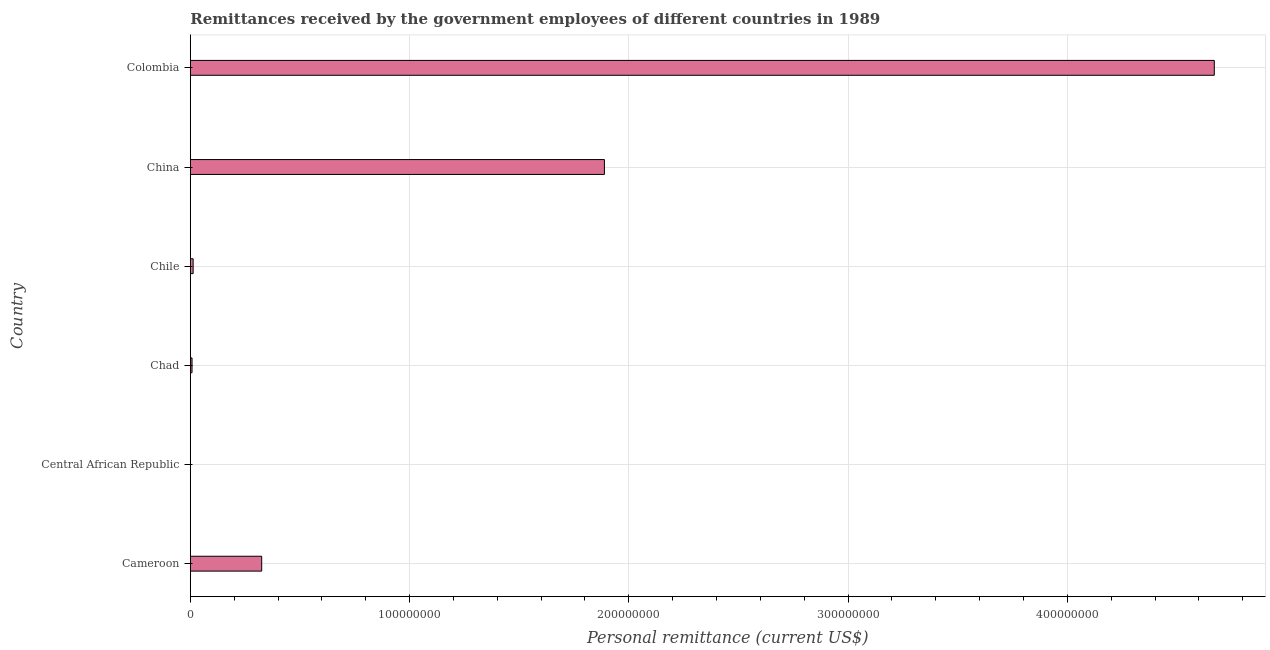Does the graph contain any zero values?
Give a very brief answer. No. Does the graph contain grids?
Offer a very short reply. Yes. What is the title of the graph?
Make the answer very short. Remittances received by the government employees of different countries in 1989. What is the label or title of the X-axis?
Your answer should be very brief. Personal remittance (current US$). What is the label or title of the Y-axis?
Give a very brief answer. Country. What is the personal remittances in Central African Republic?
Your answer should be compact. 2.19e+04. Across all countries, what is the maximum personal remittances?
Make the answer very short. 4.67e+08. Across all countries, what is the minimum personal remittances?
Offer a terse response. 2.19e+04. In which country was the personal remittances minimum?
Your answer should be compact. Central African Republic. What is the sum of the personal remittances?
Make the answer very short. 6.91e+08. What is the difference between the personal remittances in Central African Republic and Chad?
Offer a very short reply. -7.71e+05. What is the average personal remittances per country?
Your response must be concise. 1.15e+08. What is the median personal remittances?
Provide a succinct answer. 1.69e+07. What is the ratio of the personal remittances in Cameroon to that in Colombia?
Provide a short and direct response. 0.07. Is the personal remittances in Central African Republic less than that in Colombia?
Make the answer very short. Yes. Is the difference between the personal remittances in China and Colombia greater than the difference between any two countries?
Make the answer very short. No. What is the difference between the highest and the second highest personal remittances?
Offer a very short reply. 2.78e+08. What is the difference between the highest and the lowest personal remittances?
Your answer should be very brief. 4.67e+08. In how many countries, is the personal remittances greater than the average personal remittances taken over all countries?
Your answer should be compact. 2. How many bars are there?
Keep it short and to the point. 6. Are all the bars in the graph horizontal?
Ensure brevity in your answer.  Yes. How many countries are there in the graph?
Provide a succinct answer. 6. What is the difference between two consecutive major ticks on the X-axis?
Ensure brevity in your answer.  1.00e+08. What is the Personal remittance (current US$) in Cameroon?
Your response must be concise. 3.26e+07. What is the Personal remittance (current US$) of Central African Republic?
Provide a short and direct response. 2.19e+04. What is the Personal remittance (current US$) in Chad?
Your answer should be very brief. 7.93e+05. What is the Personal remittance (current US$) in Chile?
Provide a short and direct response. 1.30e+06. What is the Personal remittance (current US$) in China?
Your answer should be very brief. 1.89e+08. What is the Personal remittance (current US$) of Colombia?
Make the answer very short. 4.67e+08. What is the difference between the Personal remittance (current US$) in Cameroon and Central African Republic?
Give a very brief answer. 3.25e+07. What is the difference between the Personal remittance (current US$) in Cameroon and Chad?
Your response must be concise. 3.18e+07. What is the difference between the Personal remittance (current US$) in Cameroon and Chile?
Ensure brevity in your answer.  3.13e+07. What is the difference between the Personal remittance (current US$) in Cameroon and China?
Your response must be concise. -1.56e+08. What is the difference between the Personal remittance (current US$) in Cameroon and Colombia?
Offer a terse response. -4.34e+08. What is the difference between the Personal remittance (current US$) in Central African Republic and Chad?
Ensure brevity in your answer.  -7.71e+05. What is the difference between the Personal remittance (current US$) in Central African Republic and Chile?
Offer a terse response. -1.28e+06. What is the difference between the Personal remittance (current US$) in Central African Republic and China?
Ensure brevity in your answer.  -1.89e+08. What is the difference between the Personal remittance (current US$) in Central African Republic and Colombia?
Give a very brief answer. -4.67e+08. What is the difference between the Personal remittance (current US$) in Chad and Chile?
Provide a succinct answer. -5.07e+05. What is the difference between the Personal remittance (current US$) in Chad and China?
Your response must be concise. -1.88e+08. What is the difference between the Personal remittance (current US$) in Chad and Colombia?
Your answer should be compact. -4.66e+08. What is the difference between the Personal remittance (current US$) in Chile and China?
Offer a terse response. -1.88e+08. What is the difference between the Personal remittance (current US$) in Chile and Colombia?
Your answer should be compact. -4.66e+08. What is the difference between the Personal remittance (current US$) in China and Colombia?
Give a very brief answer. -2.78e+08. What is the ratio of the Personal remittance (current US$) in Cameroon to that in Central African Republic?
Give a very brief answer. 1484.29. What is the ratio of the Personal remittance (current US$) in Cameroon to that in Chad?
Keep it short and to the point. 41.07. What is the ratio of the Personal remittance (current US$) in Cameroon to that in Chile?
Your response must be concise. 25.05. What is the ratio of the Personal remittance (current US$) in Cameroon to that in China?
Your answer should be compact. 0.17. What is the ratio of the Personal remittance (current US$) in Cameroon to that in Colombia?
Keep it short and to the point. 0.07. What is the ratio of the Personal remittance (current US$) in Central African Republic to that in Chad?
Your response must be concise. 0.03. What is the ratio of the Personal remittance (current US$) in Central African Republic to that in Chile?
Your answer should be compact. 0.02. What is the ratio of the Personal remittance (current US$) in Central African Republic to that in China?
Provide a short and direct response. 0. What is the ratio of the Personal remittance (current US$) in Central African Republic to that in Colombia?
Provide a succinct answer. 0. What is the ratio of the Personal remittance (current US$) in Chad to that in Chile?
Ensure brevity in your answer.  0.61. What is the ratio of the Personal remittance (current US$) in Chad to that in China?
Your response must be concise. 0. What is the ratio of the Personal remittance (current US$) in Chad to that in Colombia?
Offer a very short reply. 0. What is the ratio of the Personal remittance (current US$) in Chile to that in China?
Ensure brevity in your answer.  0.01. What is the ratio of the Personal remittance (current US$) in Chile to that in Colombia?
Make the answer very short. 0. What is the ratio of the Personal remittance (current US$) in China to that in Colombia?
Your answer should be compact. 0.4. 